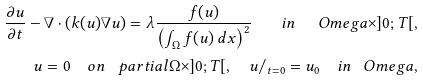Convert formula to latex. <formula><loc_0><loc_0><loc_500><loc_500>\frac { \partial u } { \partial t } - \nabla \cdot ( k ( u ) \nabla u ) = \lambda \frac { f ( u ) } { \left ( \int _ { \Omega } f ( u ) \, d x \right ) ^ { 2 } } \quad i n \ \ \ O m e g a \times ] 0 ; T [ , \\ u = 0 \quad o n \ \ \ p a r t i a l \Omega \times ] 0 ; T [ , \quad u / _ { t = 0 } = u _ { 0 } \quad i n \ \ \ O m e g a ,</formula> 